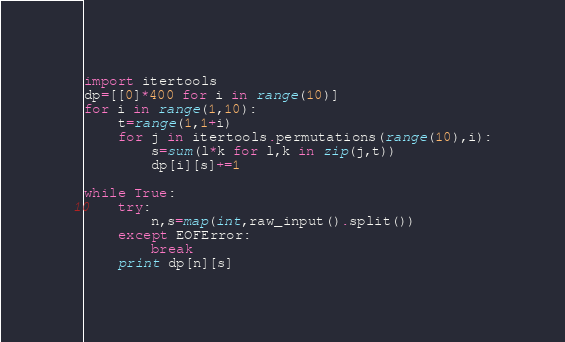Convert code to text. <code><loc_0><loc_0><loc_500><loc_500><_Python_>import itertools
dp=[[0]*400 for i in range(10)]
for i in range(1,10):
    t=range(1,1+i)
    for j in itertools.permutations(range(10),i):
        s=sum(l*k for l,k in zip(j,t))
        dp[i][s]+=1

while True:
    try:
        n,s=map(int,raw_input().split())
    except EOFError:
        break
    print dp[n][s]</code> 